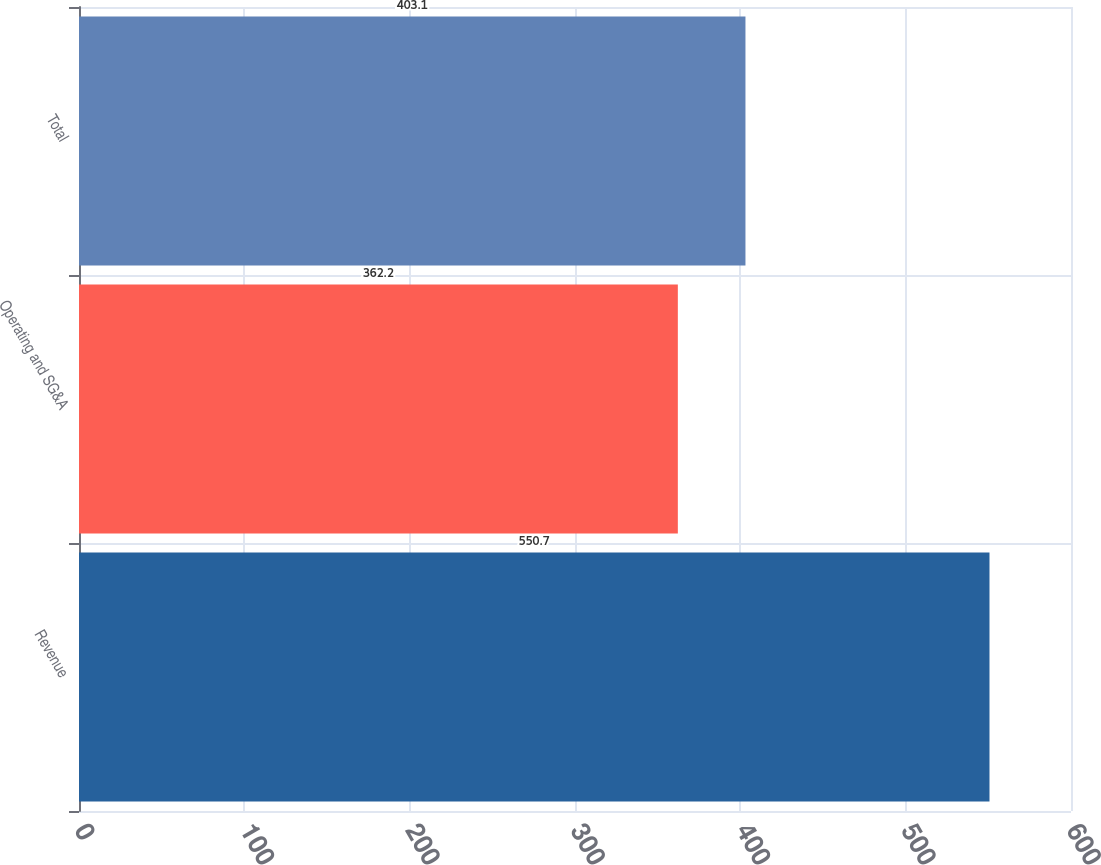<chart> <loc_0><loc_0><loc_500><loc_500><bar_chart><fcel>Revenue<fcel>Operating and SG&A<fcel>Total<nl><fcel>550.7<fcel>362.2<fcel>403.1<nl></chart> 